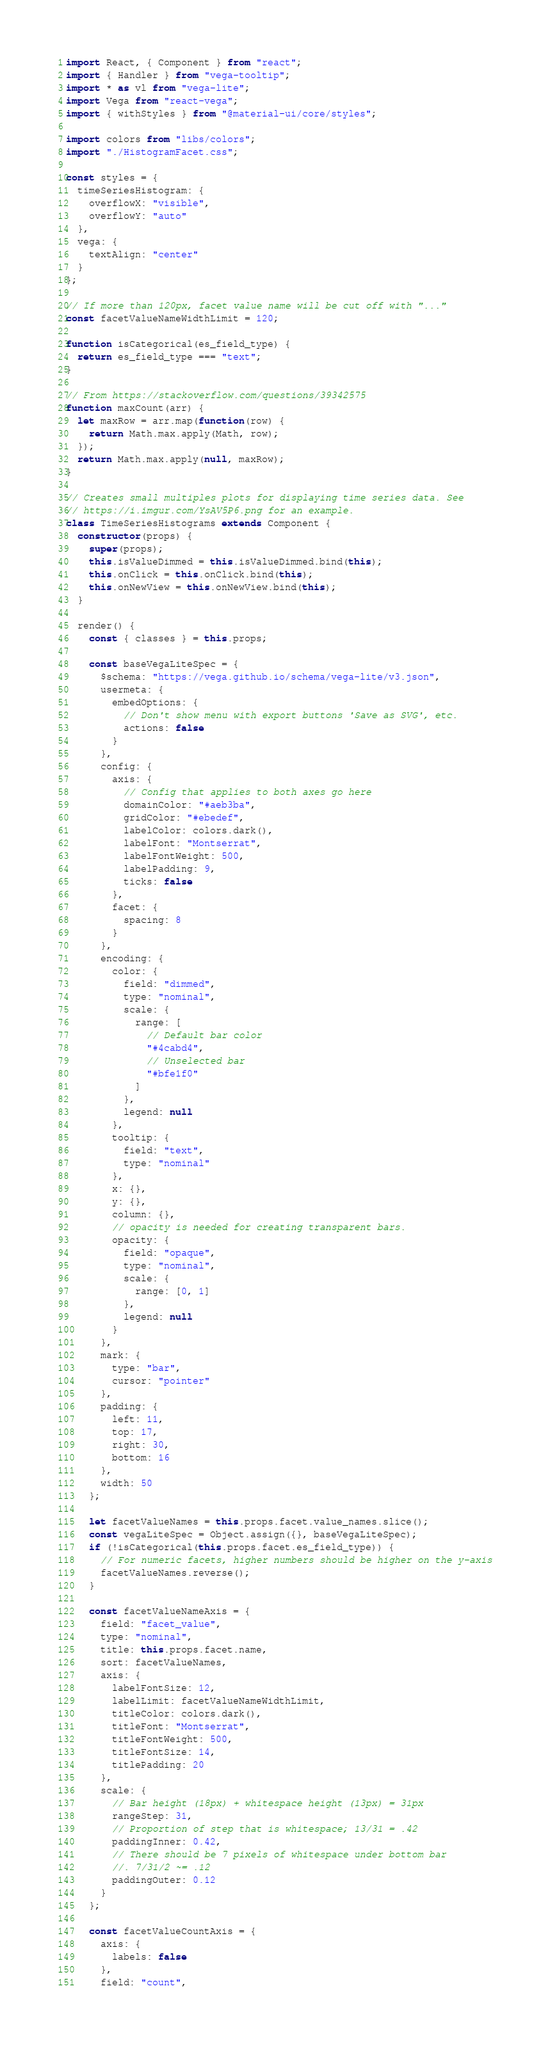Convert code to text. <code><loc_0><loc_0><loc_500><loc_500><_JavaScript_>import React, { Component } from "react";
import { Handler } from "vega-tooltip";
import * as vl from "vega-lite";
import Vega from "react-vega";
import { withStyles } from "@material-ui/core/styles";

import colors from "libs/colors";
import "./HistogramFacet.css";

const styles = {
  timeSeriesHistogram: {
    overflowX: "visible",
    overflowY: "auto"
  },
  vega: {
    textAlign: "center"
  }
};

// If more than 120px, facet value name will be cut off with "..."
const facetValueNameWidthLimit = 120;

function isCategorical(es_field_type) {
  return es_field_type === "text";
}

// From https://stackoverflow.com/questions/39342575
function maxCount(arr) {
  let maxRow = arr.map(function(row) {
    return Math.max.apply(Math, row);
  });
  return Math.max.apply(null, maxRow);
}

// Creates small multiples plots for displaying time series data. See
// https://i.imgur.com/YsAV5P6.png for an example.
class TimeSeriesHistograms extends Component {
  constructor(props) {
    super(props);
    this.isValueDimmed = this.isValueDimmed.bind(this);
    this.onClick = this.onClick.bind(this);
    this.onNewView = this.onNewView.bind(this);
  }

  render() {
    const { classes } = this.props;

    const baseVegaLiteSpec = {
      $schema: "https://vega.github.io/schema/vega-lite/v3.json",
      usermeta: {
        embedOptions: {
          // Don't show menu with export buttons 'Save as SVG', etc.
          actions: false
        }
      },
      config: {
        axis: {
          // Config that applies to both axes go here
          domainColor: "#aeb3ba",
          gridColor: "#ebedef",
          labelColor: colors.dark(),
          labelFont: "Montserrat",
          labelFontWeight: 500,
          labelPadding: 9,
          ticks: false
        },
        facet: {
          spacing: 8
        }
      },
      encoding: {
        color: {
          field: "dimmed",
          type: "nominal",
          scale: {
            range: [
              // Default bar color
              "#4cabd4",
              // Unselected bar
              "#bfe1f0"
            ]
          },
          legend: null
        },
        tooltip: {
          field: "text",
          type: "nominal"
        },
        x: {},
        y: {},
        column: {},
        // opacity is needed for creating transparent bars.
        opacity: {
          field: "opaque",
          type: "nominal",
          scale: {
            range: [0, 1]
          },
          legend: null
        }
      },
      mark: {
        type: "bar",
        cursor: "pointer"
      },
      padding: {
        left: 11,
        top: 17,
        right: 30,
        bottom: 16
      },
      width: 50
    };

    let facetValueNames = this.props.facet.value_names.slice();
    const vegaLiteSpec = Object.assign({}, baseVegaLiteSpec);
    if (!isCategorical(this.props.facet.es_field_type)) {
      // For numeric facets, higher numbers should be higher on the y-axis
      facetValueNames.reverse();
    }

    const facetValueNameAxis = {
      field: "facet_value",
      type: "nominal",
      title: this.props.facet.name,
      sort: facetValueNames,
      axis: {
        labelFontSize: 12,
        labelLimit: facetValueNameWidthLimit,
        titleColor: colors.dark(),
        titleFont: "Montserrat",
        titleFontWeight: 500,
        titleFontSize: 14,
        titlePadding: 20
      },
      scale: {
        // Bar height (18px) + whitespace height (13px) = 31px
        rangeStep: 31,
        // Proportion of step that is whitespace; 13/31 = .42
        paddingInner: 0.42,
        // There should be 7 pixels of whitespace under bottom bar
        //. 7/31/2 ~= .12
        paddingOuter: 0.12
      }
    };

    const facetValueCountAxis = {
      axis: {
        labels: false
      },
      field: "count",</code> 